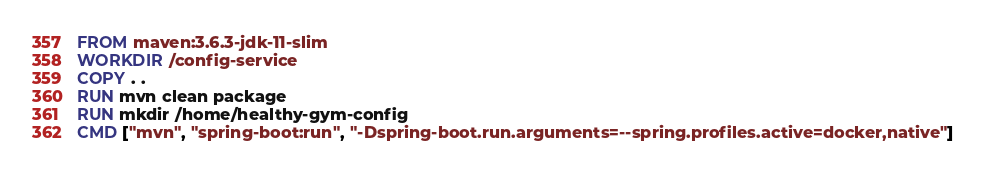Convert code to text. <code><loc_0><loc_0><loc_500><loc_500><_Dockerfile_>FROM maven:3.6.3-jdk-11-slim
WORKDIR /config-service
COPY . .
RUN mvn clean package
RUN mkdir /home/healthy-gym-config
CMD ["mvn", "spring-boot:run", "-Dspring-boot.run.arguments=--spring.profiles.active=docker,native"]</code> 